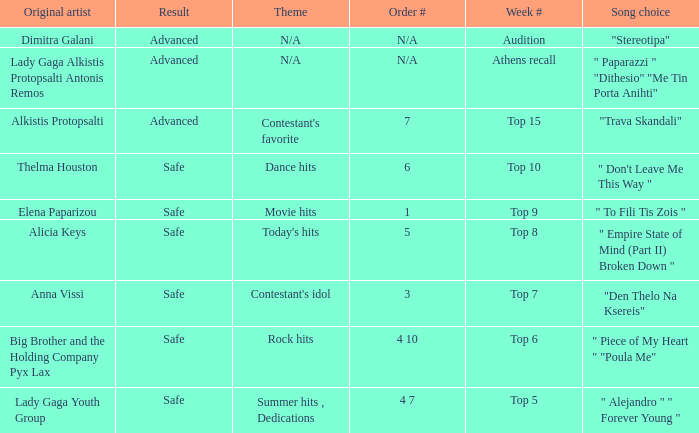Which song was chosen during the audition week? "Stereotipa". 